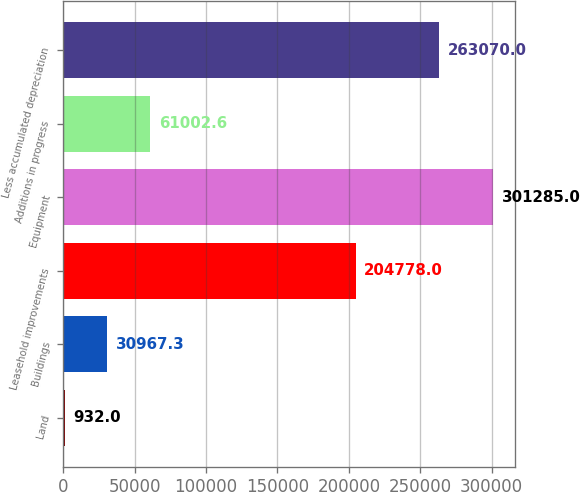Convert chart to OTSL. <chart><loc_0><loc_0><loc_500><loc_500><bar_chart><fcel>Land<fcel>Buildings<fcel>Leasehold improvements<fcel>Equipment<fcel>Additions in progress<fcel>Less accumulated depreciation<nl><fcel>932<fcel>30967.3<fcel>204778<fcel>301285<fcel>61002.6<fcel>263070<nl></chart> 